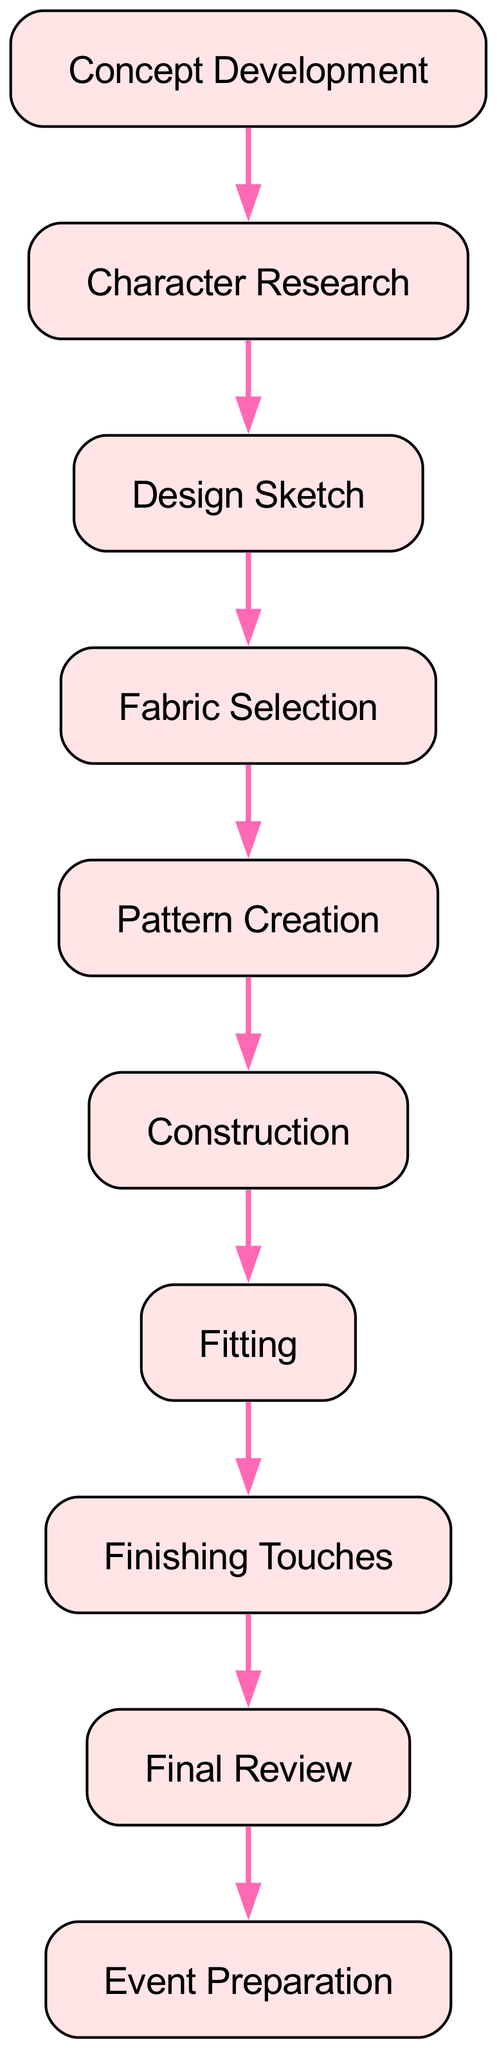What is the first step in the costume creation process? The diagram indicates that the first step is "Concept Development." This is the starting point represented at the top of the directed graph.
Answer: Concept Development How many total nodes are present in the diagram? By counting all the nodes listed in the diagram, we find that there are 10 total nodes. This includes all unique steps in the costume creation process.
Answer: 10 What is the relationship between "Construction" and "Fitting"? The diagram illustrates a directed edge pointing from "Construction" to "Fitting," indicating that "Fitting" occurs after "Construction" in the process.
Answer: Construction ➜ Fitting What step comes immediately after "Finishing Touches"? According to the diagram, "Final Review" directly follows "Finishing Touches," showing the next phase in the progression of the process.
Answer: Final Review Which step immediately precedes "Event Preparation"? The diagram shows that "Final Review" is the step that comes directly before "Event Preparation," highlighting the order in the process.
Answer: Final Review How many edges are there in the diagram? Counting the connections (edges) between nodes, we find there are 9 edges in total. Each edge represents the flow from one step to the next in the costume creation process.
Answer: 9 What is the last step in the costume creation process? The final node in the sequence of the diagram is "Event Preparation," which is the conclusion of the overall process represented.
Answer: Event Preparation Which two steps directly connect to "Fabric Selection"? The directed graph shows "Design Sketch" as the preceding step and "Pattern Creation" as the following step, indicating their direct connection to "Fabric Selection."
Answer: Design Sketch, Pattern Creation What is the last node that is linked directly to "Fitting"? According to the diagram, "Finishing Touches" is the last node linked directly to "Fitting," signifying the next step after fitting.
Answer: Finishing Touches 